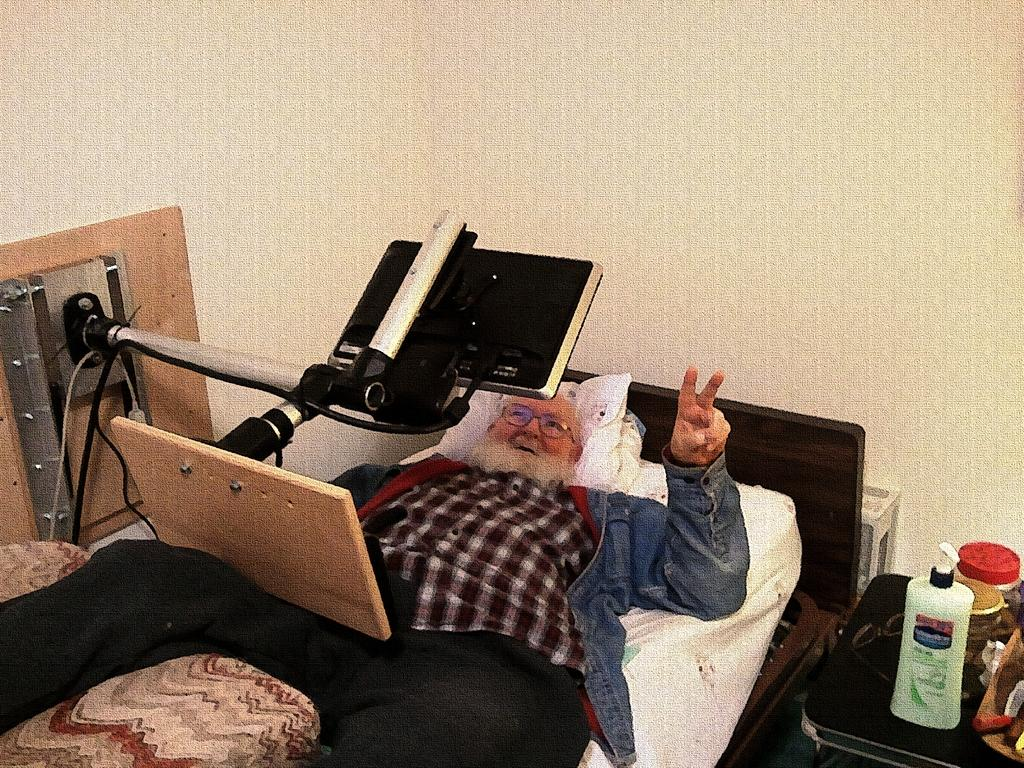What is the main subject of the image? There is a person in the image. What is the person's position in the image? The person is lying on a bed. What other objects can be seen in the image? There is a table, objects on the table, a television, a stand, and a wall in the image. What type of hose is being used by the person in the image? There is no hose present in the image. Can you tell me which judge is featured in the image? There is no judge present in the image. 